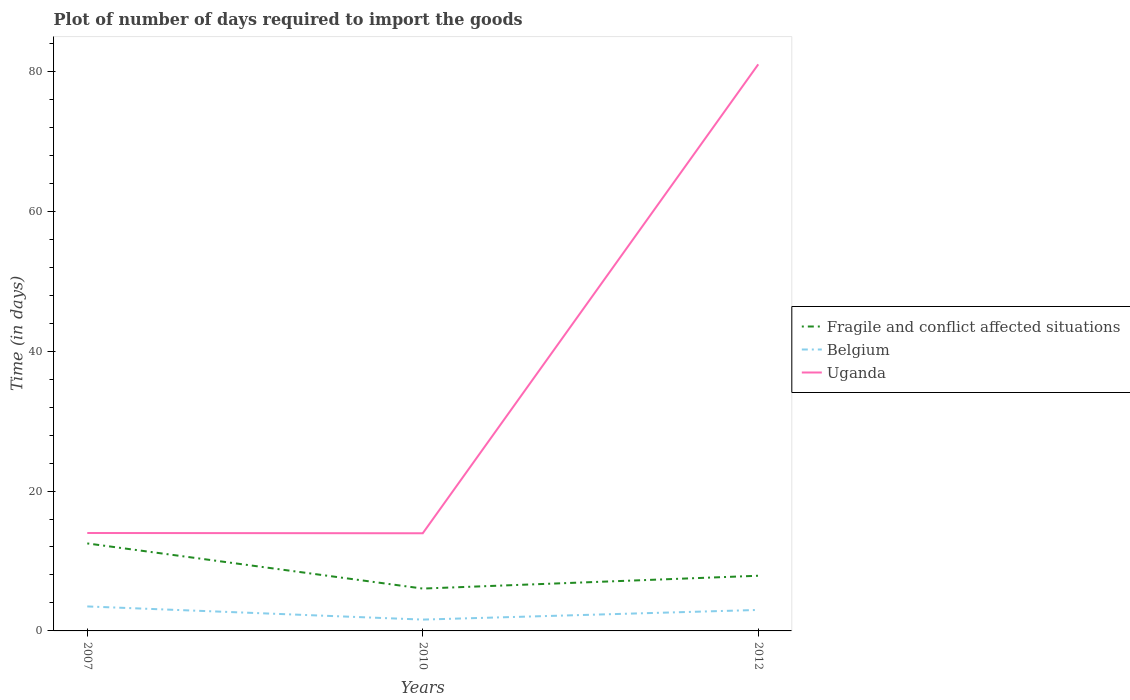Is the number of lines equal to the number of legend labels?
Make the answer very short. Yes. Across all years, what is the maximum time required to import goods in Uganda?
Ensure brevity in your answer.  13.96. In which year was the time required to import goods in Fragile and conflict affected situations maximum?
Offer a very short reply. 2010. What is the total time required to import goods in Fragile and conflict affected situations in the graph?
Make the answer very short. 6.45. What is the difference between the highest and the second highest time required to import goods in Uganda?
Offer a terse response. 67.04. What is the difference between the highest and the lowest time required to import goods in Belgium?
Keep it short and to the point. 2. How many years are there in the graph?
Provide a succinct answer. 3. What is the difference between two consecutive major ticks on the Y-axis?
Offer a terse response. 20. Are the values on the major ticks of Y-axis written in scientific E-notation?
Your answer should be very brief. No. Does the graph contain any zero values?
Make the answer very short. No. Does the graph contain grids?
Ensure brevity in your answer.  No. Where does the legend appear in the graph?
Make the answer very short. Center right. How are the legend labels stacked?
Make the answer very short. Vertical. What is the title of the graph?
Give a very brief answer. Plot of number of days required to import the goods. What is the label or title of the X-axis?
Your answer should be very brief. Years. What is the label or title of the Y-axis?
Make the answer very short. Time (in days). What is the Time (in days) in Fragile and conflict affected situations in 2007?
Make the answer very short. 12.51. What is the Time (in days) in Belgium in 2007?
Ensure brevity in your answer.  3.5. What is the Time (in days) of Fragile and conflict affected situations in 2010?
Give a very brief answer. 6.05. What is the Time (in days) of Belgium in 2010?
Your response must be concise. 1.62. What is the Time (in days) of Uganda in 2010?
Provide a short and direct response. 13.96. What is the Time (in days) in Fragile and conflict affected situations in 2012?
Provide a short and direct response. 7.89. What is the Time (in days) of Belgium in 2012?
Ensure brevity in your answer.  3. What is the Time (in days) of Uganda in 2012?
Offer a terse response. 81. Across all years, what is the maximum Time (in days) in Fragile and conflict affected situations?
Provide a short and direct response. 12.51. Across all years, what is the minimum Time (in days) in Fragile and conflict affected situations?
Your answer should be very brief. 6.05. Across all years, what is the minimum Time (in days) of Belgium?
Give a very brief answer. 1.62. Across all years, what is the minimum Time (in days) in Uganda?
Provide a short and direct response. 13.96. What is the total Time (in days) of Fragile and conflict affected situations in the graph?
Keep it short and to the point. 26.45. What is the total Time (in days) in Belgium in the graph?
Your answer should be very brief. 8.12. What is the total Time (in days) of Uganda in the graph?
Your answer should be compact. 108.96. What is the difference between the Time (in days) of Fragile and conflict affected situations in 2007 and that in 2010?
Keep it short and to the point. 6.45. What is the difference between the Time (in days) of Belgium in 2007 and that in 2010?
Offer a very short reply. 1.88. What is the difference between the Time (in days) of Fragile and conflict affected situations in 2007 and that in 2012?
Provide a short and direct response. 4.62. What is the difference between the Time (in days) of Uganda in 2007 and that in 2012?
Keep it short and to the point. -67. What is the difference between the Time (in days) in Fragile and conflict affected situations in 2010 and that in 2012?
Provide a short and direct response. -1.83. What is the difference between the Time (in days) in Belgium in 2010 and that in 2012?
Your response must be concise. -1.38. What is the difference between the Time (in days) of Uganda in 2010 and that in 2012?
Your response must be concise. -67.04. What is the difference between the Time (in days) of Fragile and conflict affected situations in 2007 and the Time (in days) of Belgium in 2010?
Provide a succinct answer. 10.89. What is the difference between the Time (in days) in Fragile and conflict affected situations in 2007 and the Time (in days) in Uganda in 2010?
Your answer should be very brief. -1.45. What is the difference between the Time (in days) of Belgium in 2007 and the Time (in days) of Uganda in 2010?
Give a very brief answer. -10.46. What is the difference between the Time (in days) in Fragile and conflict affected situations in 2007 and the Time (in days) in Belgium in 2012?
Your answer should be compact. 9.51. What is the difference between the Time (in days) of Fragile and conflict affected situations in 2007 and the Time (in days) of Uganda in 2012?
Offer a very short reply. -68.49. What is the difference between the Time (in days) in Belgium in 2007 and the Time (in days) in Uganda in 2012?
Your answer should be very brief. -77.5. What is the difference between the Time (in days) in Fragile and conflict affected situations in 2010 and the Time (in days) in Belgium in 2012?
Make the answer very short. 3.06. What is the difference between the Time (in days) in Fragile and conflict affected situations in 2010 and the Time (in days) in Uganda in 2012?
Keep it short and to the point. -74.94. What is the difference between the Time (in days) in Belgium in 2010 and the Time (in days) in Uganda in 2012?
Provide a short and direct response. -79.38. What is the average Time (in days) of Fragile and conflict affected situations per year?
Keep it short and to the point. 8.82. What is the average Time (in days) in Belgium per year?
Offer a terse response. 2.71. What is the average Time (in days) in Uganda per year?
Provide a short and direct response. 36.32. In the year 2007, what is the difference between the Time (in days) of Fragile and conflict affected situations and Time (in days) of Belgium?
Your response must be concise. 9.01. In the year 2007, what is the difference between the Time (in days) of Fragile and conflict affected situations and Time (in days) of Uganda?
Offer a very short reply. -1.49. In the year 2007, what is the difference between the Time (in days) of Belgium and Time (in days) of Uganda?
Your answer should be compact. -10.5. In the year 2010, what is the difference between the Time (in days) of Fragile and conflict affected situations and Time (in days) of Belgium?
Offer a terse response. 4.43. In the year 2010, what is the difference between the Time (in days) of Fragile and conflict affected situations and Time (in days) of Uganda?
Make the answer very short. -7.91. In the year 2010, what is the difference between the Time (in days) in Belgium and Time (in days) in Uganda?
Make the answer very short. -12.34. In the year 2012, what is the difference between the Time (in days) of Fragile and conflict affected situations and Time (in days) of Belgium?
Ensure brevity in your answer.  4.89. In the year 2012, what is the difference between the Time (in days) of Fragile and conflict affected situations and Time (in days) of Uganda?
Give a very brief answer. -73.11. In the year 2012, what is the difference between the Time (in days) of Belgium and Time (in days) of Uganda?
Offer a terse response. -78. What is the ratio of the Time (in days) of Fragile and conflict affected situations in 2007 to that in 2010?
Make the answer very short. 2.07. What is the ratio of the Time (in days) of Belgium in 2007 to that in 2010?
Provide a succinct answer. 2.16. What is the ratio of the Time (in days) of Fragile and conflict affected situations in 2007 to that in 2012?
Make the answer very short. 1.59. What is the ratio of the Time (in days) in Belgium in 2007 to that in 2012?
Your answer should be very brief. 1.17. What is the ratio of the Time (in days) of Uganda in 2007 to that in 2012?
Provide a succinct answer. 0.17. What is the ratio of the Time (in days) of Fragile and conflict affected situations in 2010 to that in 2012?
Give a very brief answer. 0.77. What is the ratio of the Time (in days) of Belgium in 2010 to that in 2012?
Offer a very short reply. 0.54. What is the ratio of the Time (in days) of Uganda in 2010 to that in 2012?
Make the answer very short. 0.17. What is the difference between the highest and the second highest Time (in days) in Fragile and conflict affected situations?
Your answer should be very brief. 4.62. What is the difference between the highest and the second highest Time (in days) in Uganda?
Offer a terse response. 67. What is the difference between the highest and the lowest Time (in days) of Fragile and conflict affected situations?
Ensure brevity in your answer.  6.45. What is the difference between the highest and the lowest Time (in days) of Belgium?
Ensure brevity in your answer.  1.88. What is the difference between the highest and the lowest Time (in days) in Uganda?
Provide a succinct answer. 67.04. 